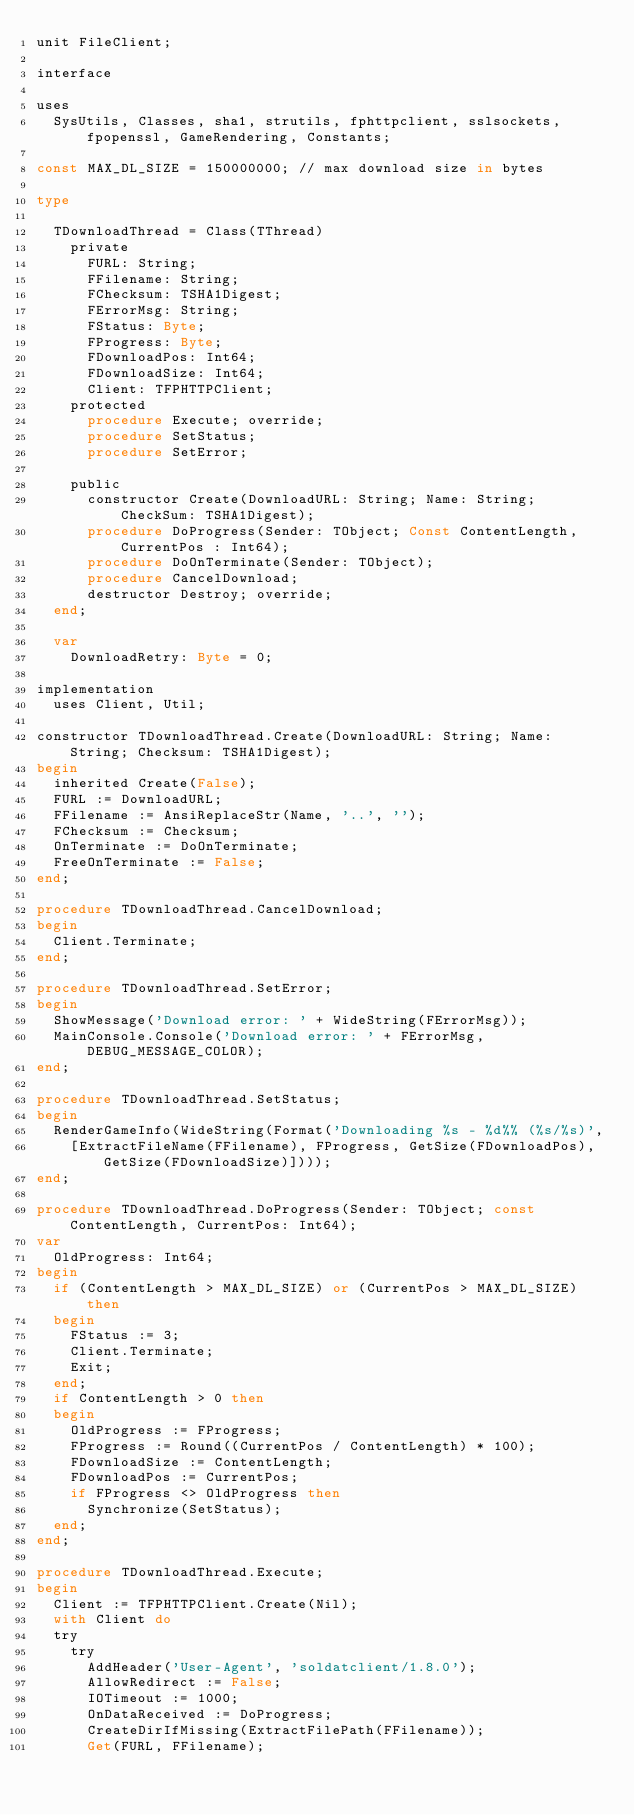<code> <loc_0><loc_0><loc_500><loc_500><_Pascal_>unit FileClient;

interface

uses
  SysUtils, Classes, sha1, strutils, fphttpclient, sslsockets, fpopenssl, GameRendering, Constants;

const MAX_DL_SIZE = 150000000; // max download size in bytes

type

  TDownloadThread = Class(TThread)
    private
      FURL: String;
      FFilename: String;
      FChecksum: TSHA1Digest;
      FErrorMsg: String;
      FStatus: Byte;
      FProgress: Byte;
      FDownloadPos: Int64;
      FDownloadSize: Int64;
      Client: TFPHTTPClient;
    protected
      procedure Execute; override;
      procedure SetStatus;
      procedure SetError;

    public
      constructor Create(DownloadURL: String; Name: String; CheckSum: TSHA1Digest);
      procedure DoProgress(Sender: TObject; Const ContentLength, CurrentPos : Int64);
      procedure DoOnTerminate(Sender: TObject);
      procedure CancelDownload;
      destructor Destroy; override;
  end;

  var
    DownloadRetry: Byte = 0;

implementation
  uses Client, Util;

constructor TDownloadThread.Create(DownloadURL: String; Name: String; Checksum: TSHA1Digest);
begin
  inherited Create(False);
  FURL := DownloadURL;
  FFilename := AnsiReplaceStr(Name, '..', '');
  FChecksum := Checksum;
  OnTerminate := DoOnTerminate;
  FreeOnTerminate := False;
end;

procedure TDownloadThread.CancelDownload;
begin
  Client.Terminate;
end;

procedure TDownloadThread.SetError;
begin
  ShowMessage('Download error: ' + WideString(FErrorMsg));
  MainConsole.Console('Download error: ' + FErrorMsg, DEBUG_MESSAGE_COLOR);
end;

procedure TDownloadThread.SetStatus;
begin
  RenderGameInfo(WideString(Format('Downloading %s - %d%% (%s/%s)',
    [ExtractFileName(FFilename), FProgress, GetSize(FDownloadPos), GetSize(FDownloadSize)])));
end;

procedure TDownloadThread.DoProgress(Sender: TObject; const ContentLength, CurrentPos: Int64);
var
  OldProgress: Int64;
begin
  if (ContentLength > MAX_DL_SIZE) or (CurrentPos > MAX_DL_SIZE) then
  begin
    FStatus := 3;
    Client.Terminate;
    Exit;
  end;
  if ContentLength > 0 then
  begin
    OldProgress := FProgress;
    FProgress := Round((CurrentPos / ContentLength) * 100);
    FDownloadSize := ContentLength;
    FDownloadPos := CurrentPos;
    if FProgress <> OldProgress then
      Synchronize(SetStatus);
  end;
end;

procedure TDownloadThread.Execute;
begin
  Client := TFPHTTPClient.Create(Nil);
  with Client do
  try
    try
      AddHeader('User-Agent', 'soldatclient/1.8.0');
      AllowRedirect := False;
      IOTimeout := 1000;
      OnDataReceived := DoProgress;
      CreateDirIfMissing(ExtractFilePath(FFilename));
      Get(FURL, FFilename);</code> 